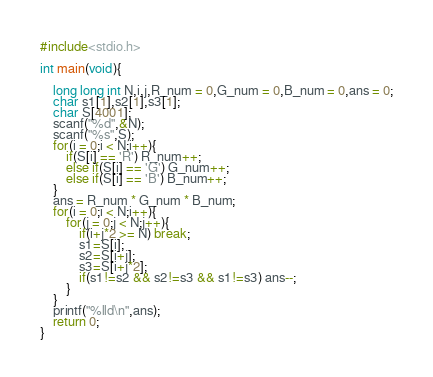<code> <loc_0><loc_0><loc_500><loc_500><_C_>#include<stdio.h>
 
int main(void){
 
    long long int N,i,j,R_num = 0,G_num = 0,B_num = 0,ans = 0;
  	char s1[1],s2[1],s3[1];
    char S[4001];
    scanf("%d",&N);
    scanf("%s",S);
    for(i = 0;i < N;i++){
        if(S[i] == 'R') R_num++;
        else if(S[i] == 'G') G_num++;
        else if(S[i] == 'B') B_num++;
    }
    ans = R_num * G_num * B_num;
    for(i = 0;i < N;i++){
        for(j = 0;j < N;j++){
            if(i+j*2 >= N) break;
          	s1=S[i];
          	s2=S[i+j];
          	s3=S[i+j*2];
            if(s1!=s2 && s2!=s3 && s1!=s3) ans--;
        }
    }
    printf("%lld\n",ans);
    return 0;
}</code> 